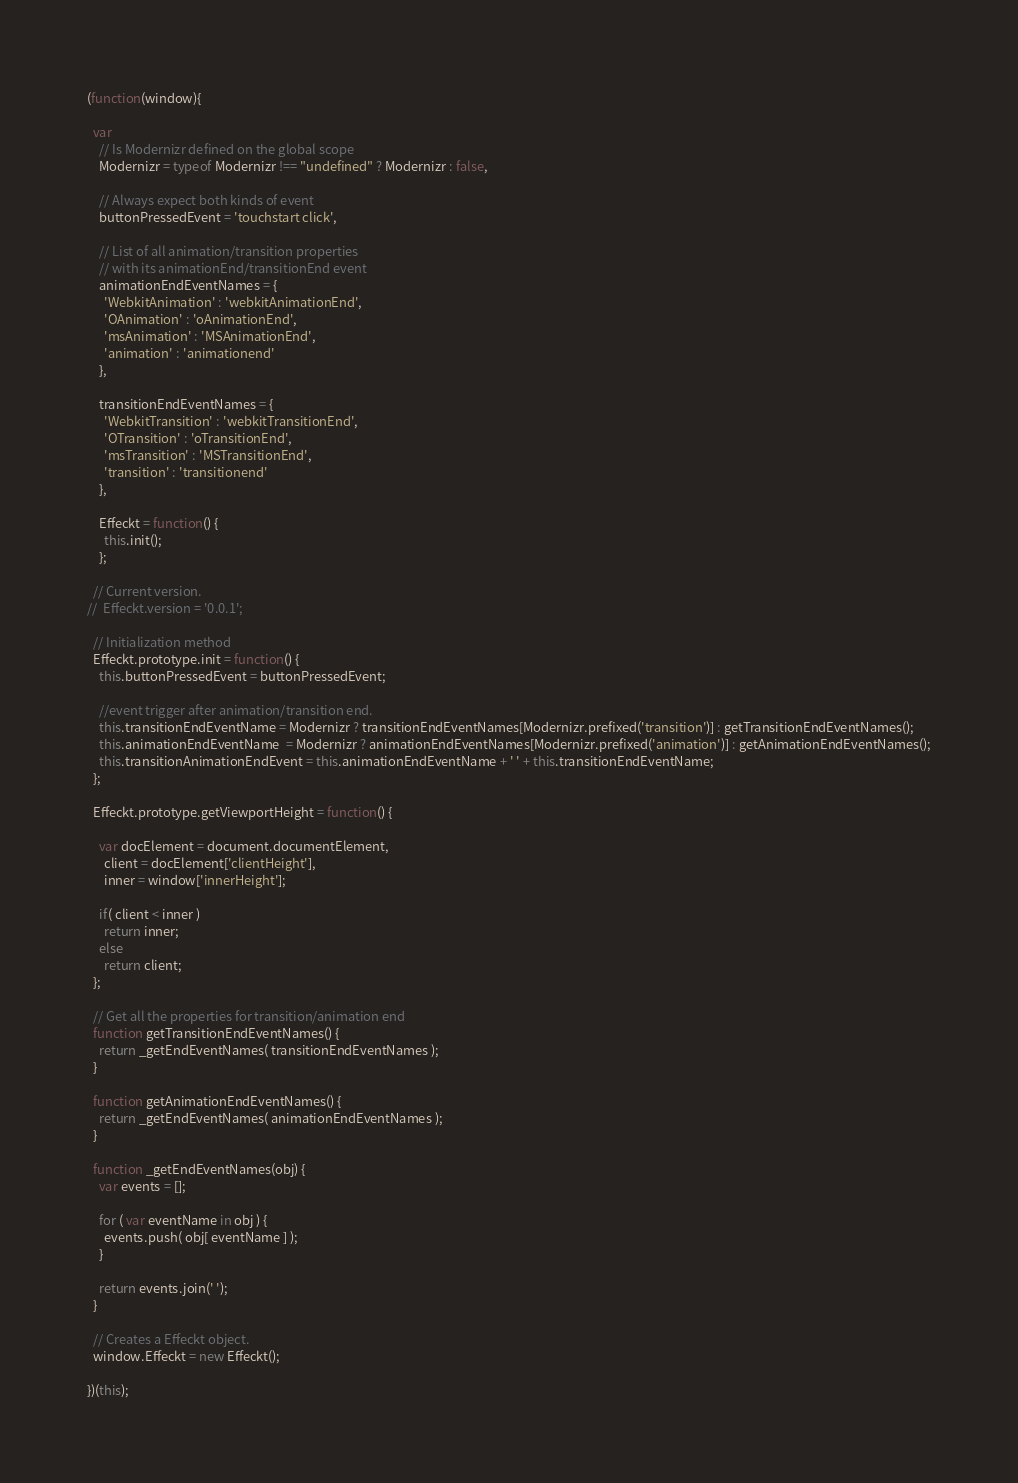Convert code to text. <code><loc_0><loc_0><loc_500><loc_500><_JavaScript_>(function(window){

  var
    // Is Modernizr defined on the global scope
    Modernizr = typeof Modernizr !== "undefined" ? Modernizr : false,

    // Always expect both kinds of event
    buttonPressedEvent = 'touchstart click',

    // List of all animation/transition properties
    // with its animationEnd/transitionEnd event
    animationEndEventNames = {
      'WebkitAnimation' : 'webkitAnimationEnd',
      'OAnimation' : 'oAnimationEnd',
      'msAnimation' : 'MSAnimationEnd',
      'animation' : 'animationend'
    },

    transitionEndEventNames = {
      'WebkitTransition' : 'webkitTransitionEnd',
      'OTransition' : 'oTransitionEnd',
      'msTransition' : 'MSTransitionEnd',
      'transition' : 'transitionend'
    },

    Effeckt = function() {
      this.init();
    };

  // Current version.
//  Effeckt.version = '0.0.1';

  // Initialization method
  Effeckt.prototype.init = function() {
    this.buttonPressedEvent = buttonPressedEvent;

    //event trigger after animation/transition end.
    this.transitionEndEventName = Modernizr ? transitionEndEventNames[Modernizr.prefixed('transition')] : getTransitionEndEventNames();
    this.animationEndEventName  = Modernizr ? animationEndEventNames[Modernizr.prefixed('animation')] : getAnimationEndEventNames();
    this.transitionAnimationEndEvent = this.animationEndEventName + ' ' + this.transitionEndEventName;
  };

  Effeckt.prototype.getViewportHeight = function() {

    var docElement = document.documentElement,
      client = docElement['clientHeight'],
      inner = window['innerHeight'];

    if( client < inner )
      return inner;
    else
      return client;
  };

  // Get all the properties for transition/animation end
  function getTransitionEndEventNames() {
    return _getEndEventNames( transitionEndEventNames );
  }

  function getAnimationEndEventNames() {
    return _getEndEventNames( animationEndEventNames );
  }

  function _getEndEventNames(obj) {
    var events = [];

    for ( var eventName in obj ) {
      events.push( obj[ eventName ] );
    }

    return events.join(' ');
  }

  // Creates a Effeckt object.
  window.Effeckt = new Effeckt();

})(this);
</code> 